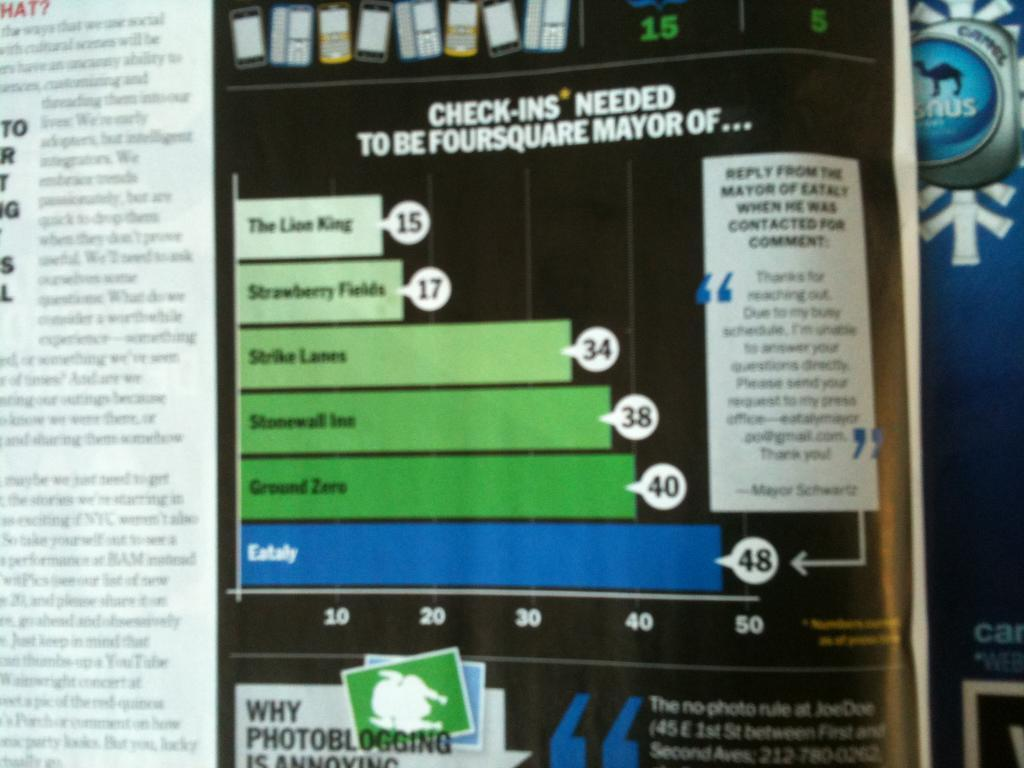<image>
Create a compact narrative representing the image presented. A page of a magazine shows a graph about the number of Check-ins needed to be the foursquare mayor of multiple things. 